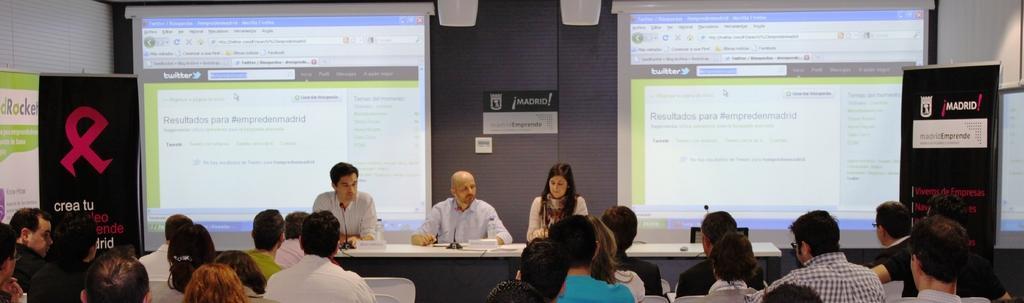Could you give a brief overview of what you see in this image? In this image we can see some group of persons sitting on chairs and in the background of the image there are three persons sitting on chairs behind table on which there are some microphones, name boards, bottles and we can see projector screens, boards. 